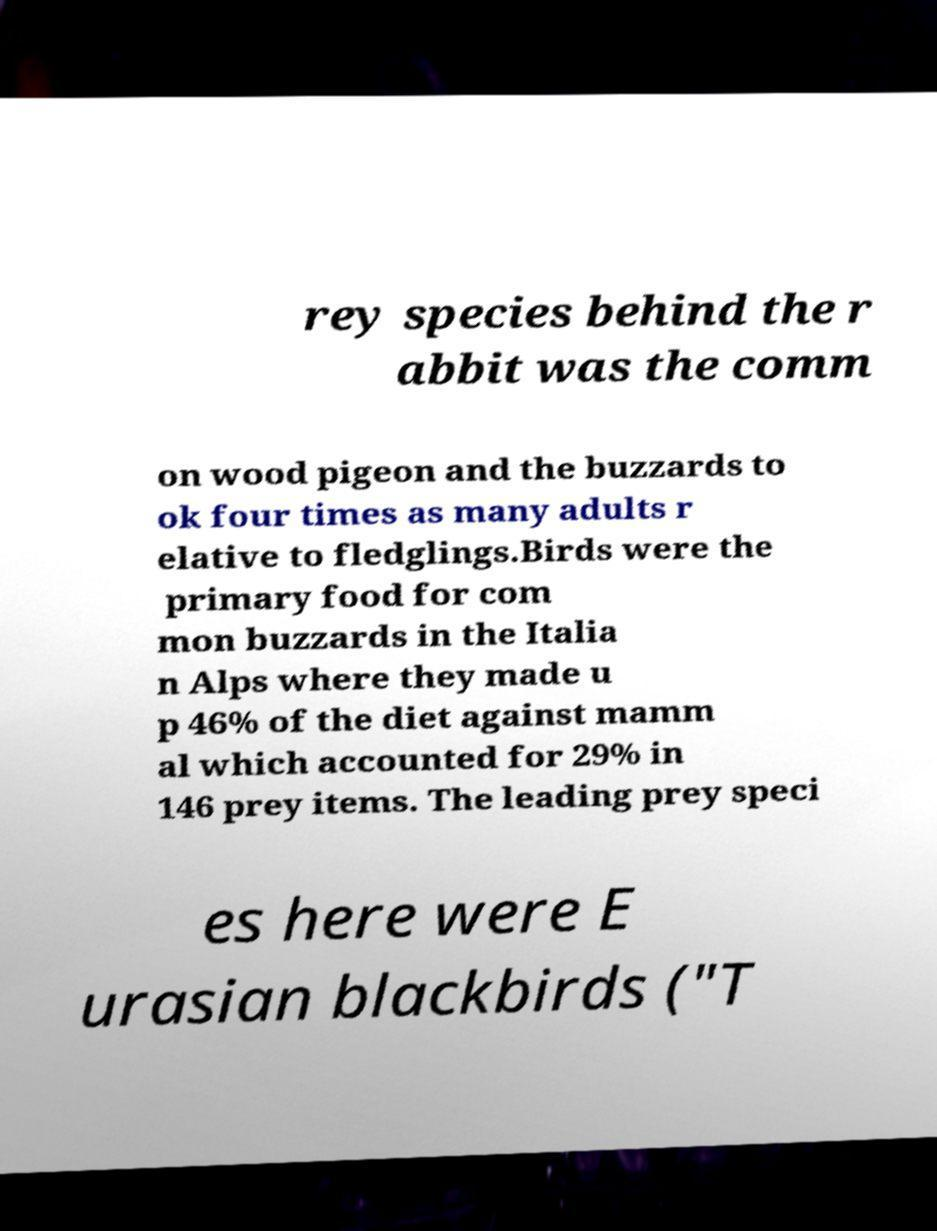What messages or text are displayed in this image? I need them in a readable, typed format. rey species behind the r abbit was the comm on wood pigeon and the buzzards to ok four times as many adults r elative to fledglings.Birds were the primary food for com mon buzzards in the Italia n Alps where they made u p 46% of the diet against mamm al which accounted for 29% in 146 prey items. The leading prey speci es here were E urasian blackbirds ("T 